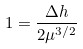<formula> <loc_0><loc_0><loc_500><loc_500>1 = \frac { \Delta h } { 2 \mu ^ { 3 / 2 } }</formula> 